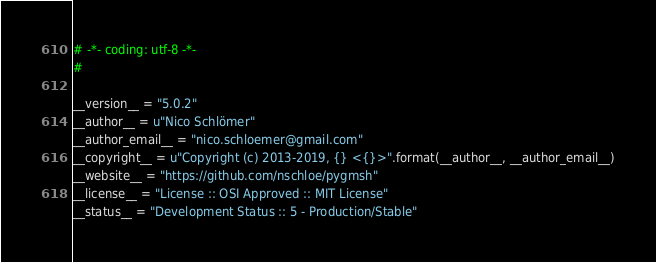<code> <loc_0><loc_0><loc_500><loc_500><_Python_># -*- coding: utf-8 -*-
#

__version__ = "5.0.2"
__author__ = u"Nico Schlömer"
__author_email__ = "nico.schloemer@gmail.com"
__copyright__ = u"Copyright (c) 2013-2019, {} <{}>".format(__author__, __author_email__)
__website__ = "https://github.com/nschloe/pygmsh"
__license__ = "License :: OSI Approved :: MIT License"
__status__ = "Development Status :: 5 - Production/Stable"
</code> 